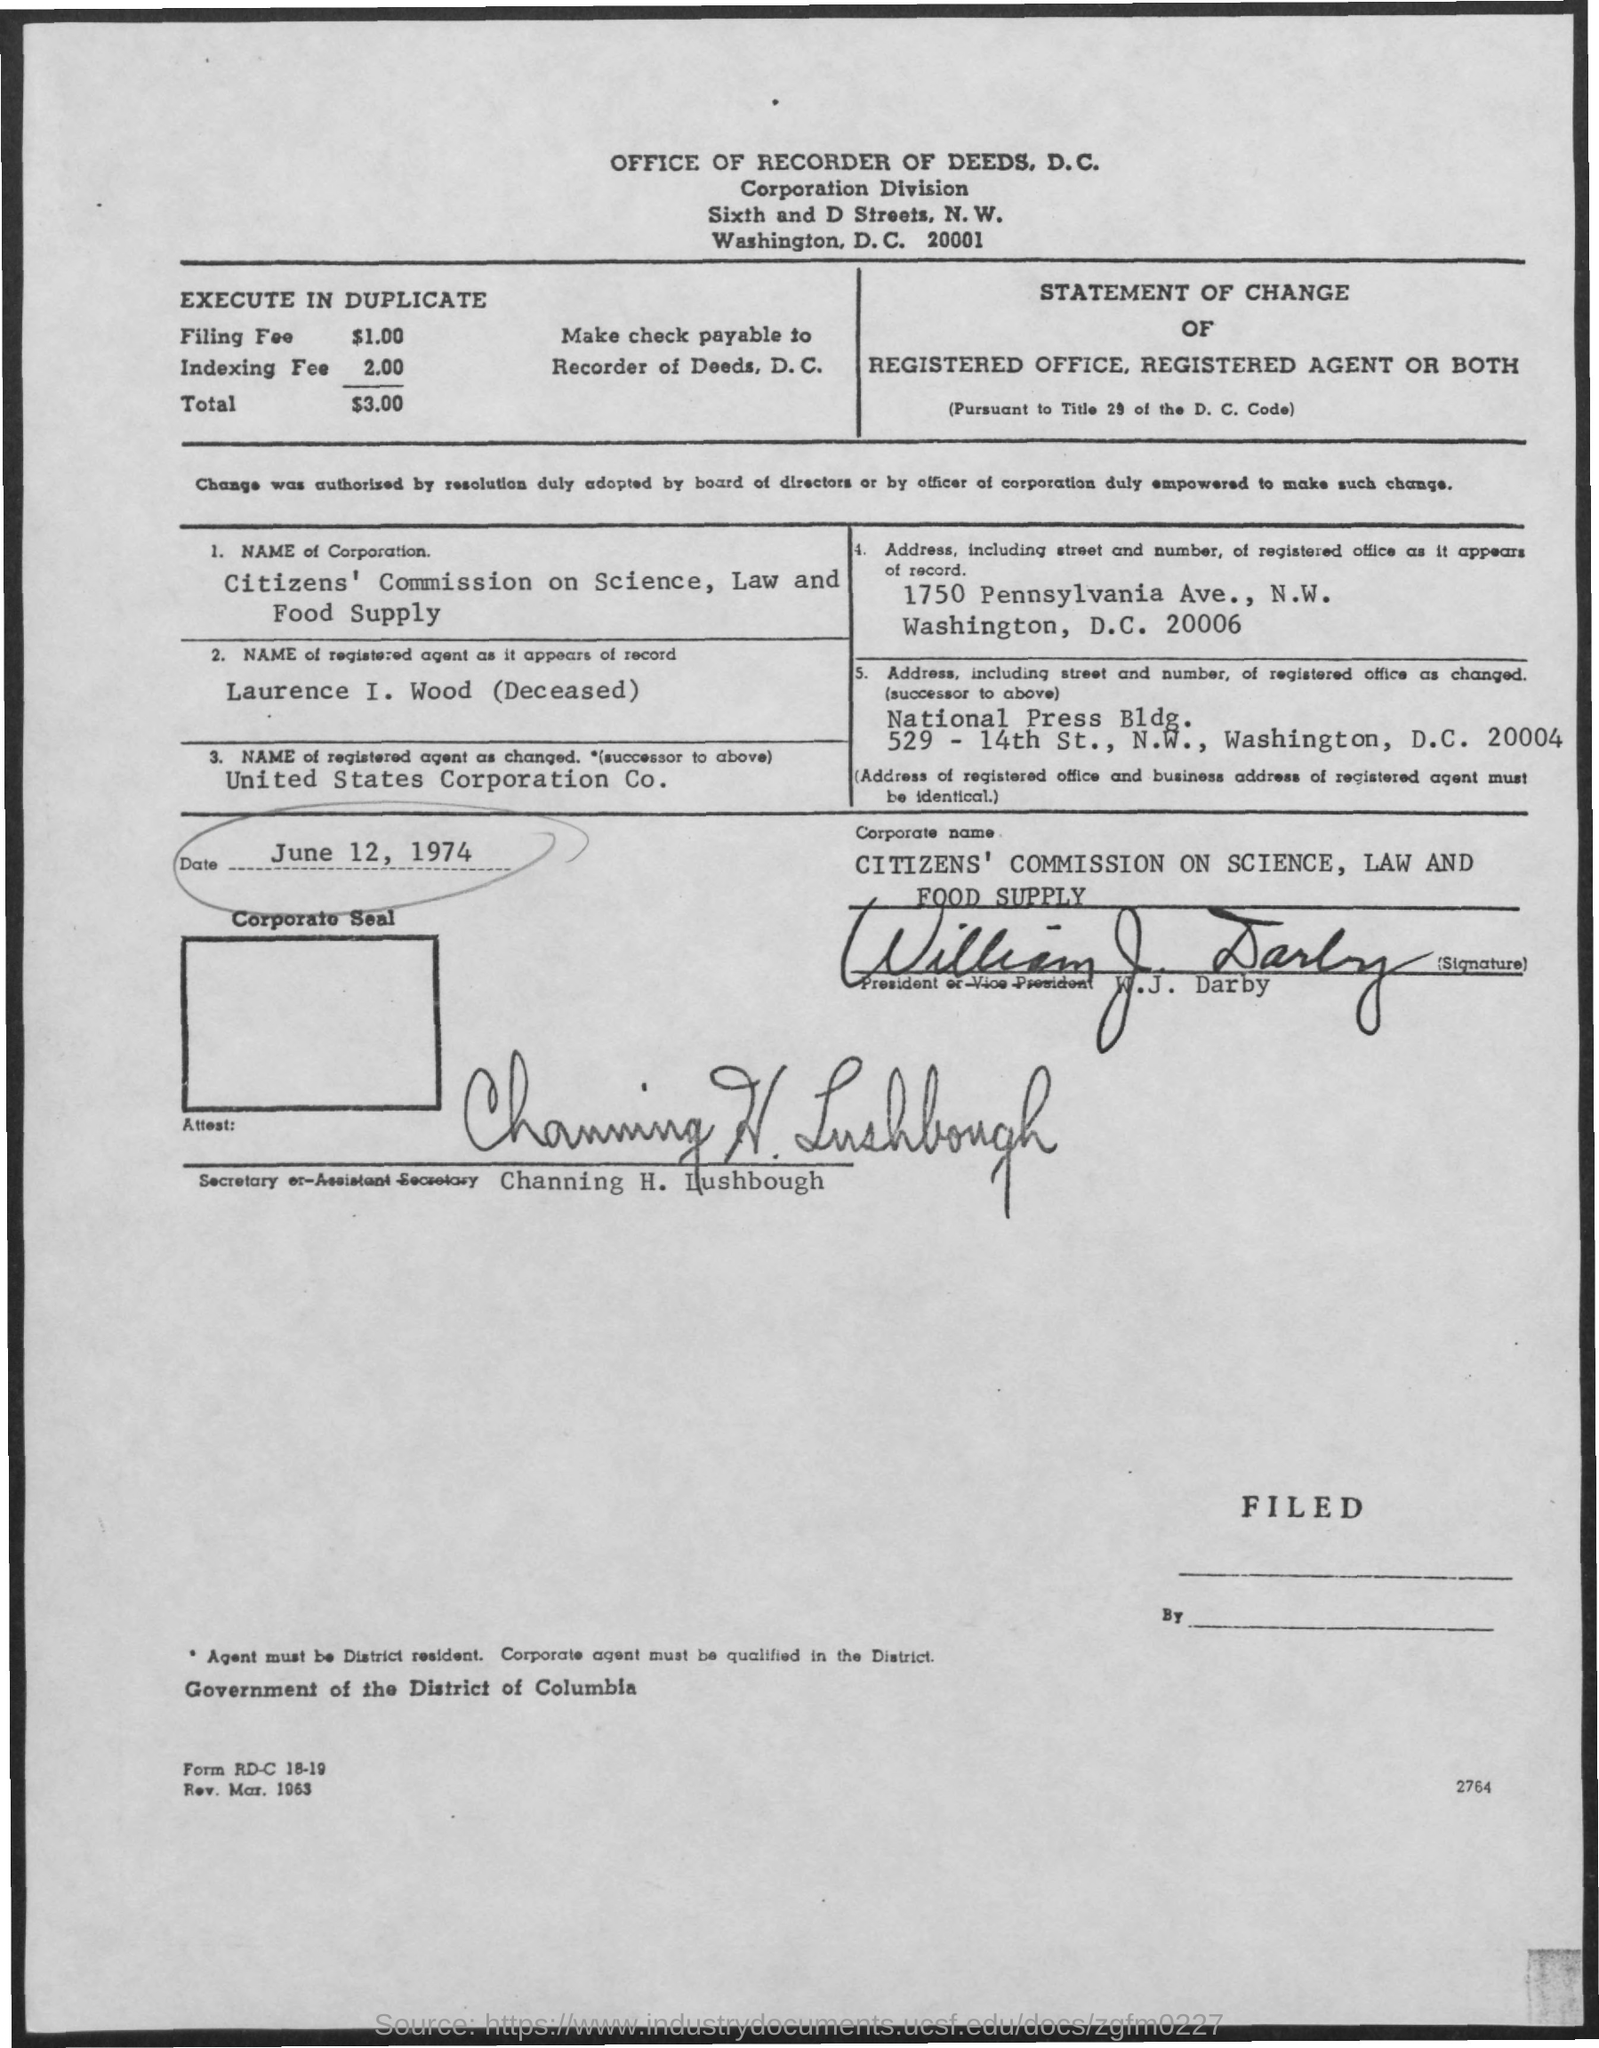What is the name of corporation given?
Your response must be concise. Citizens' Commission on Science, Law and Food Supply. What is the name of registered agent as it appears of record?
Provide a short and direct response. Laurence I. Wood  (Deceased). What is the name of the registered agent as changed?
Keep it short and to the point. United States Corporation Co. What is the date mentioned?
Offer a very short reply. June 12, 1974. Who is the Secretary or-Assistant Secretary?
Provide a succinct answer. Channing H. Lushbough. 